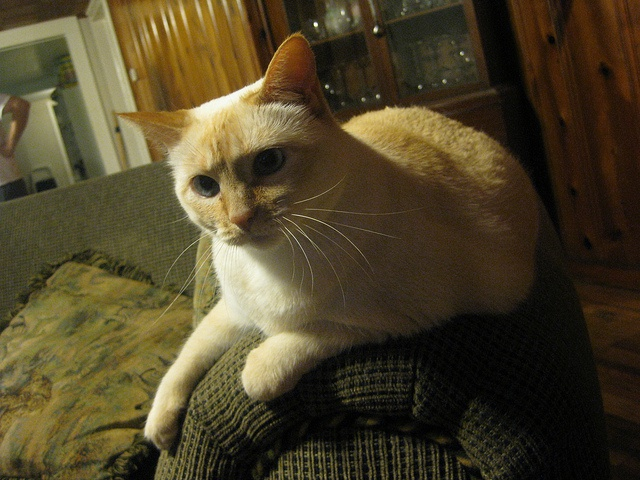Describe the objects in this image and their specific colors. I can see couch in black, olive, and gray tones, cat in black, olive, and tan tones, cup in black, darkgreen, and gray tones, wine glass in black, darkgreen, and gray tones, and cup in black, darkgreen, and gray tones in this image. 